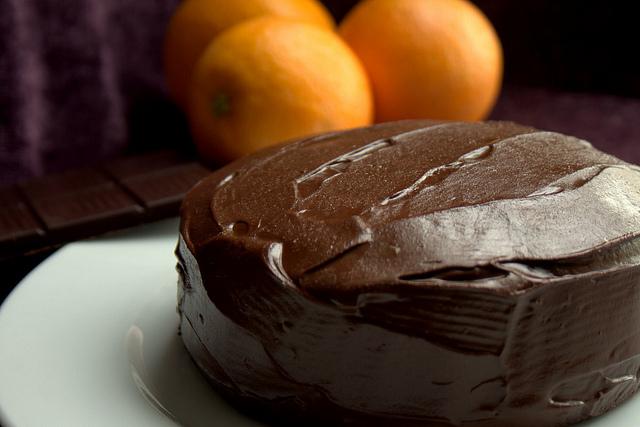Do you think this cake tastes good?
Keep it brief. Yes. Will the oranges be eaten with the cake?
Write a very short answer. No. What flavor is the cake?
Quick response, please. Chocolate. 